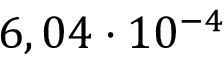<formula> <loc_0><loc_0><loc_500><loc_500>6 , 0 4 \cdot 1 0 ^ { - 4 }</formula> 